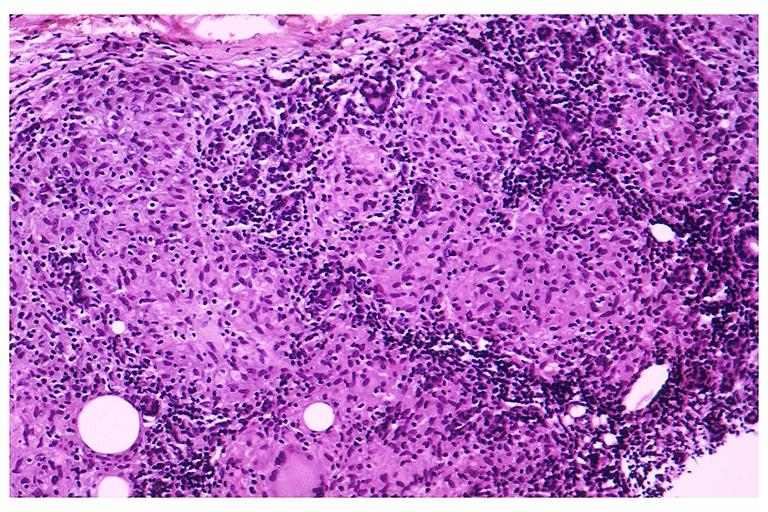does this image show sarcoidosis?
Answer the question using a single word or phrase. Yes 